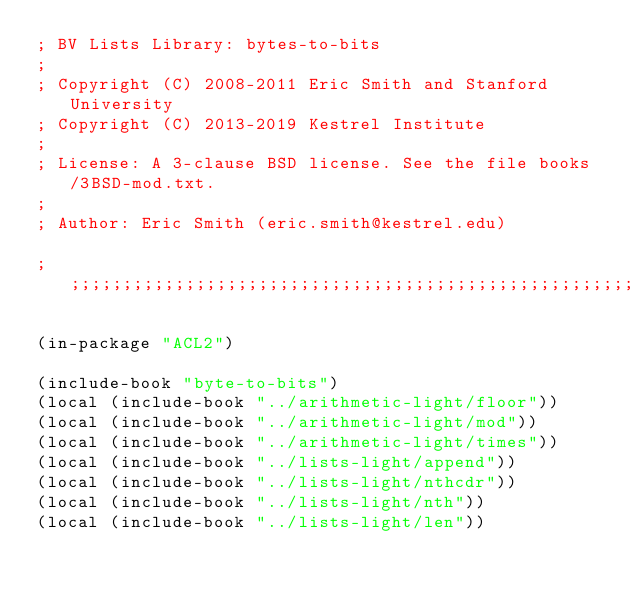<code> <loc_0><loc_0><loc_500><loc_500><_Lisp_>; BV Lists Library: bytes-to-bits
;
; Copyright (C) 2008-2011 Eric Smith and Stanford University
; Copyright (C) 2013-2019 Kestrel Institute
;
; License: A 3-clause BSD license. See the file books/3BSD-mod.txt.
;
; Author: Eric Smith (eric.smith@kestrel.edu)

;;;;;;;;;;;;;;;;;;;;;;;;;;;;;;;;;;;;;;;;;;;;;;;;;;;;;;;;;;;;;;;;;;;;;;;;;;;;;;;;

(in-package "ACL2")

(include-book "byte-to-bits")
(local (include-book "../arithmetic-light/floor"))
(local (include-book "../arithmetic-light/mod"))
(local (include-book "../arithmetic-light/times"))
(local (include-book "../lists-light/append"))
(local (include-book "../lists-light/nthcdr"))
(local (include-book "../lists-light/nth"))
(local (include-book "../lists-light/len"))</code> 